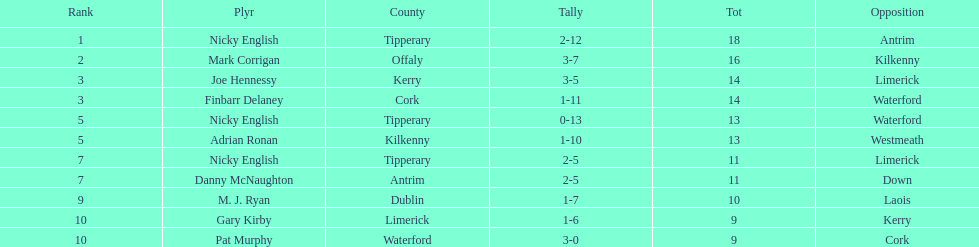Joe hennessy and finbarr delaney both scored how many points? 14. 